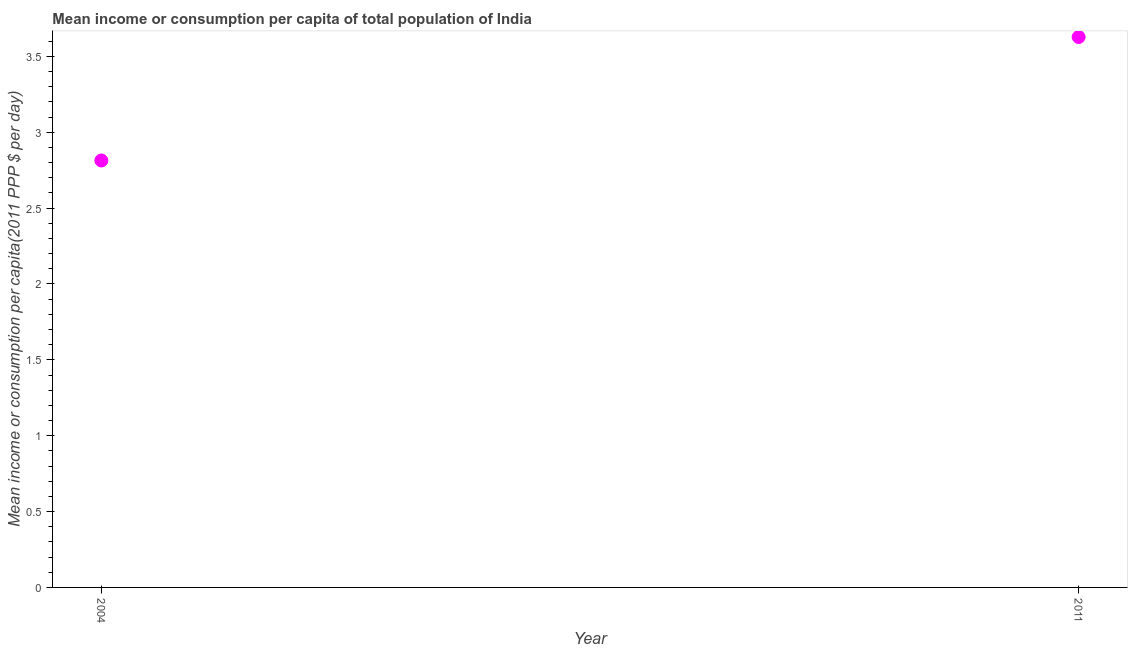What is the mean income or consumption in 2011?
Keep it short and to the point. 3.63. Across all years, what is the maximum mean income or consumption?
Your answer should be compact. 3.63. Across all years, what is the minimum mean income or consumption?
Ensure brevity in your answer.  2.81. In which year was the mean income or consumption minimum?
Your response must be concise. 2004. What is the sum of the mean income or consumption?
Provide a succinct answer. 6.44. What is the difference between the mean income or consumption in 2004 and 2011?
Your response must be concise. -0.81. What is the average mean income or consumption per year?
Provide a short and direct response. 3.22. What is the median mean income or consumption?
Keep it short and to the point. 3.22. In how many years, is the mean income or consumption greater than 3.3 $?
Your response must be concise. 1. What is the ratio of the mean income or consumption in 2004 to that in 2011?
Your response must be concise. 0.78. Is the mean income or consumption in 2004 less than that in 2011?
Give a very brief answer. Yes. How many dotlines are there?
Provide a short and direct response. 1. What is the difference between two consecutive major ticks on the Y-axis?
Ensure brevity in your answer.  0.5. Does the graph contain grids?
Offer a very short reply. No. What is the title of the graph?
Provide a short and direct response. Mean income or consumption per capita of total population of India. What is the label or title of the Y-axis?
Your response must be concise. Mean income or consumption per capita(2011 PPP $ per day). What is the Mean income or consumption per capita(2011 PPP $ per day) in 2004?
Ensure brevity in your answer.  2.81. What is the Mean income or consumption per capita(2011 PPP $ per day) in 2011?
Your response must be concise. 3.63. What is the difference between the Mean income or consumption per capita(2011 PPP $ per day) in 2004 and 2011?
Provide a succinct answer. -0.81. What is the ratio of the Mean income or consumption per capita(2011 PPP $ per day) in 2004 to that in 2011?
Provide a short and direct response. 0.78. 